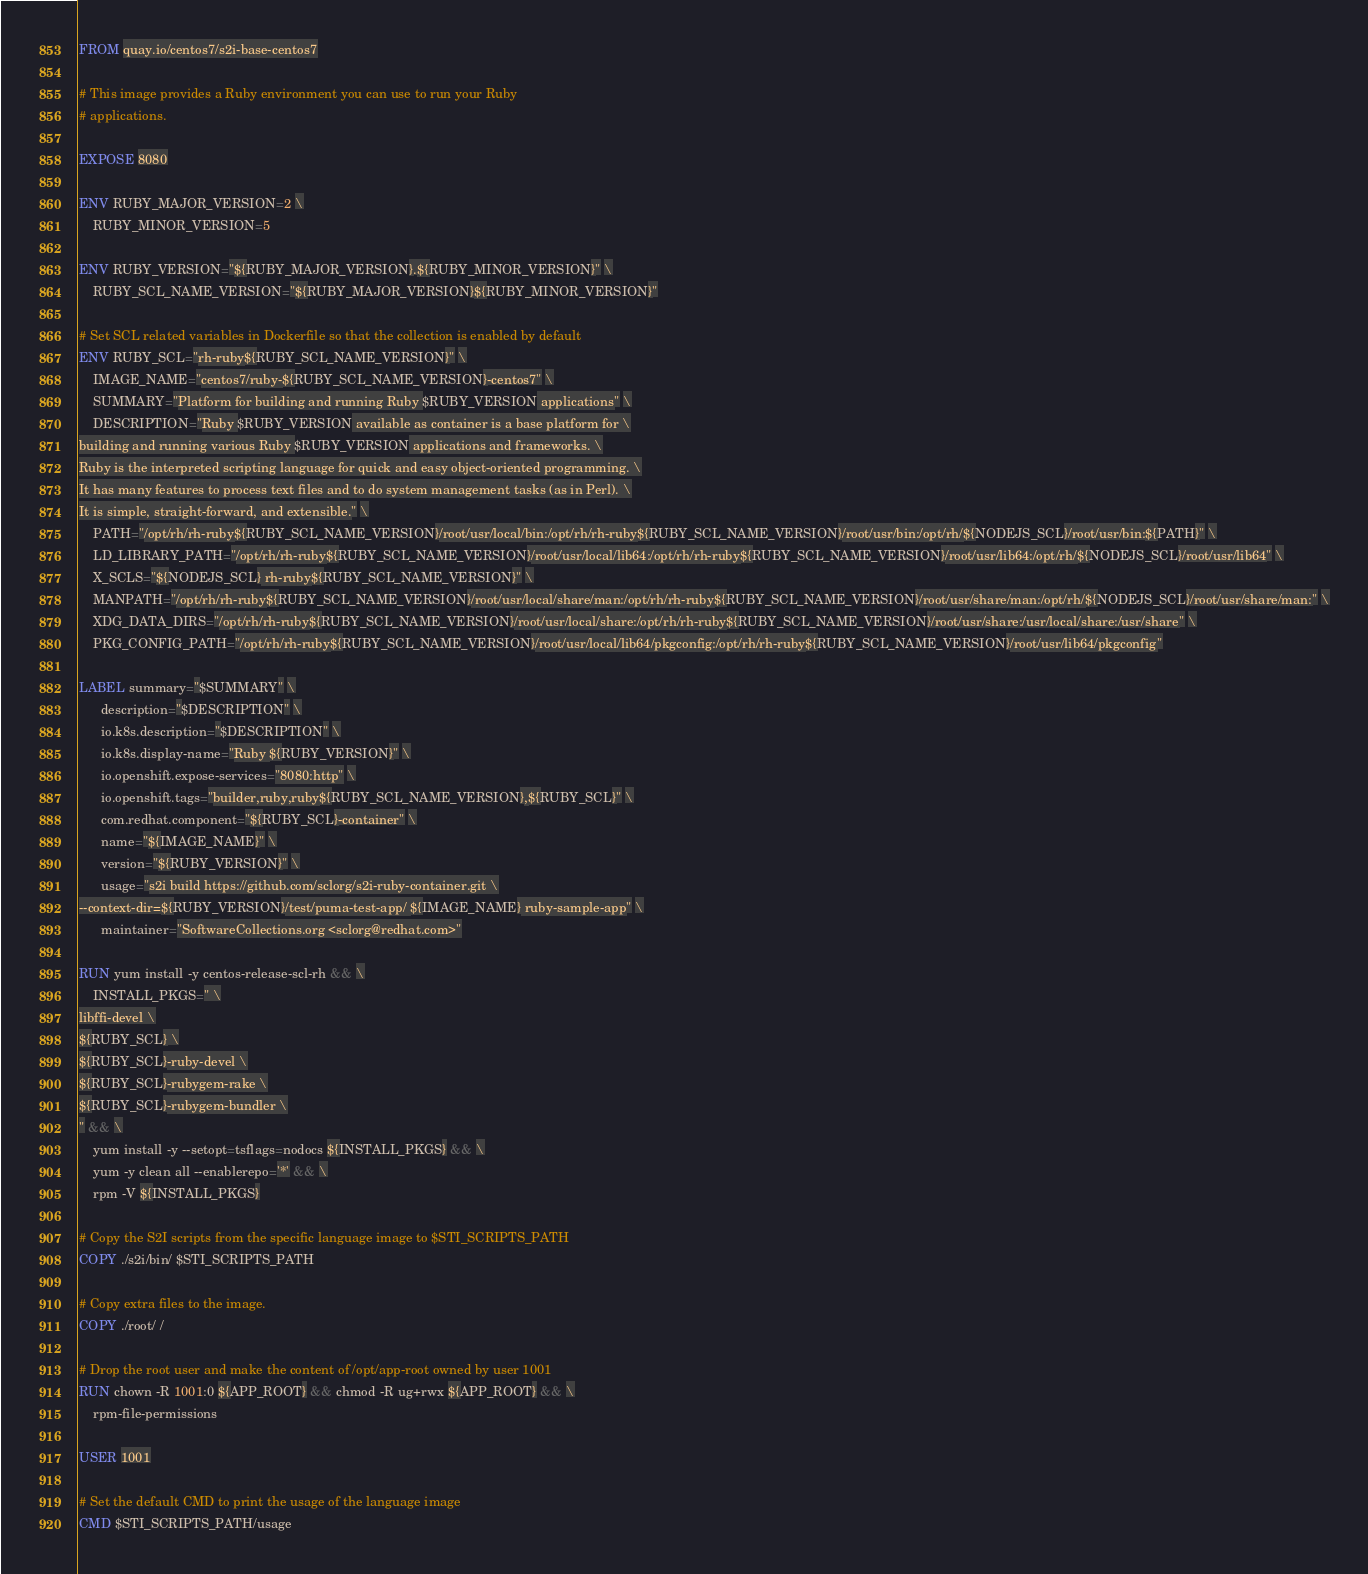<code> <loc_0><loc_0><loc_500><loc_500><_Dockerfile_>FROM quay.io/centos7/s2i-base-centos7

# This image provides a Ruby environment you can use to run your Ruby
# applications.

EXPOSE 8080

ENV RUBY_MAJOR_VERSION=2 \
    RUBY_MINOR_VERSION=5

ENV RUBY_VERSION="${RUBY_MAJOR_VERSION}.${RUBY_MINOR_VERSION}" \
    RUBY_SCL_NAME_VERSION="${RUBY_MAJOR_VERSION}${RUBY_MINOR_VERSION}"

# Set SCL related variables in Dockerfile so that the collection is enabled by default
ENV RUBY_SCL="rh-ruby${RUBY_SCL_NAME_VERSION}" \
    IMAGE_NAME="centos7/ruby-${RUBY_SCL_NAME_VERSION}-centos7" \
    SUMMARY="Platform for building and running Ruby $RUBY_VERSION applications" \
    DESCRIPTION="Ruby $RUBY_VERSION available as container is a base platform for \
building and running various Ruby $RUBY_VERSION applications and frameworks. \
Ruby is the interpreted scripting language for quick and easy object-oriented programming. \
It has many features to process text files and to do system management tasks (as in Perl). \
It is simple, straight-forward, and extensible." \
    PATH="/opt/rh/rh-ruby${RUBY_SCL_NAME_VERSION}/root/usr/local/bin:/opt/rh/rh-ruby${RUBY_SCL_NAME_VERSION}/root/usr/bin:/opt/rh/${NODEJS_SCL}/root/usr/bin:${PATH}" \
    LD_LIBRARY_PATH="/opt/rh/rh-ruby${RUBY_SCL_NAME_VERSION}/root/usr/local/lib64:/opt/rh/rh-ruby${RUBY_SCL_NAME_VERSION}/root/usr/lib64:/opt/rh/${NODEJS_SCL}/root/usr/lib64" \
    X_SCLS="${NODEJS_SCL} rh-ruby${RUBY_SCL_NAME_VERSION}" \
    MANPATH="/opt/rh/rh-ruby${RUBY_SCL_NAME_VERSION}/root/usr/local/share/man:/opt/rh/rh-ruby${RUBY_SCL_NAME_VERSION}/root/usr/share/man:/opt/rh/${NODEJS_SCL}/root/usr/share/man:" \
    XDG_DATA_DIRS="/opt/rh/rh-ruby${RUBY_SCL_NAME_VERSION}/root/usr/local/share:/opt/rh/rh-ruby${RUBY_SCL_NAME_VERSION}/root/usr/share:/usr/local/share:/usr/share" \
    PKG_CONFIG_PATH="/opt/rh/rh-ruby${RUBY_SCL_NAME_VERSION}/root/usr/local/lib64/pkgconfig:/opt/rh/rh-ruby${RUBY_SCL_NAME_VERSION}/root/usr/lib64/pkgconfig"

LABEL summary="$SUMMARY" \
      description="$DESCRIPTION" \
      io.k8s.description="$DESCRIPTION" \
      io.k8s.display-name="Ruby ${RUBY_VERSION}" \
      io.openshift.expose-services="8080:http" \
      io.openshift.tags="builder,ruby,ruby${RUBY_SCL_NAME_VERSION},${RUBY_SCL}" \
      com.redhat.component="${RUBY_SCL}-container" \
      name="${IMAGE_NAME}" \
      version="${RUBY_VERSION}" \
      usage="s2i build https://github.com/sclorg/s2i-ruby-container.git \
--context-dir=${RUBY_VERSION}/test/puma-test-app/ ${IMAGE_NAME} ruby-sample-app" \
      maintainer="SoftwareCollections.org <sclorg@redhat.com>"

RUN yum install -y centos-release-scl-rh && \
    INSTALL_PKGS=" \
libffi-devel \
${RUBY_SCL} \
${RUBY_SCL}-ruby-devel \
${RUBY_SCL}-rubygem-rake \
${RUBY_SCL}-rubygem-bundler \
" && \
    yum install -y --setopt=tsflags=nodocs ${INSTALL_PKGS} && \
    yum -y clean all --enablerepo='*' && \
    rpm -V ${INSTALL_PKGS}

# Copy the S2I scripts from the specific language image to $STI_SCRIPTS_PATH
COPY ./s2i/bin/ $STI_SCRIPTS_PATH

# Copy extra files to the image.
COPY ./root/ /

# Drop the root user and make the content of /opt/app-root owned by user 1001
RUN chown -R 1001:0 ${APP_ROOT} && chmod -R ug+rwx ${APP_ROOT} && \
    rpm-file-permissions

USER 1001

# Set the default CMD to print the usage of the language image
CMD $STI_SCRIPTS_PATH/usage
</code> 